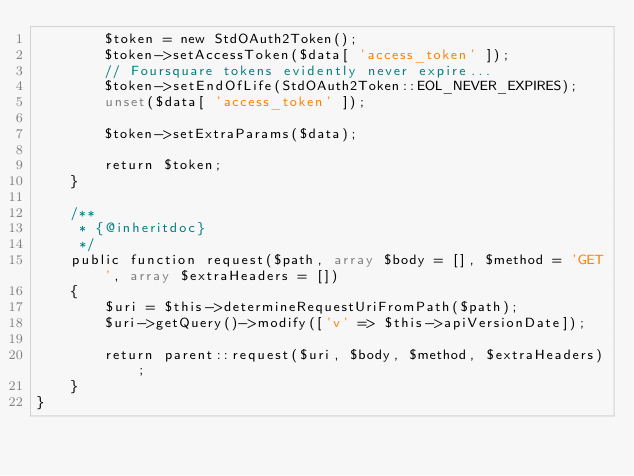<code> <loc_0><loc_0><loc_500><loc_500><_PHP_>		$token = new StdOAuth2Token();
		$token->setAccessToken($data[ 'access_token' ]);
		// Foursquare tokens evidently never expire...
		$token->setEndOfLife(StdOAuth2Token::EOL_NEVER_EXPIRES);
		unset($data[ 'access_token' ]);

		$token->setExtraParams($data);

		return $token;
	}

	/**
	 * {@inheritdoc}
	 */
	public function request($path, array $body = [], $method = 'GET', array $extraHeaders = [])
	{
		$uri = $this->determineRequestUriFromPath($path);
		$uri->getQuery()->modify(['v' => $this->apiVersionDate]);

		return parent::request($uri, $body, $method, $extraHeaders);
	}
}
</code> 